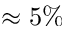Convert formula to latex. <formula><loc_0><loc_0><loc_500><loc_500>\approx 5 \%</formula> 